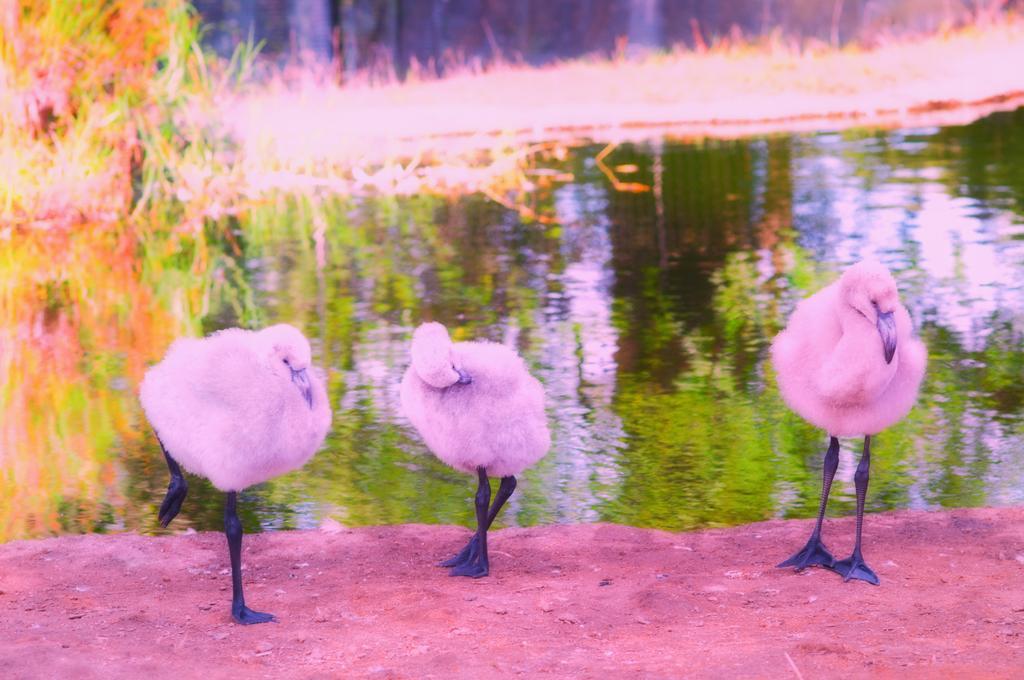Could you give a brief overview of what you see in this image? In the picture I can see pink color birds standing on the ground. In the background I can see the water, the grass and other objects. 